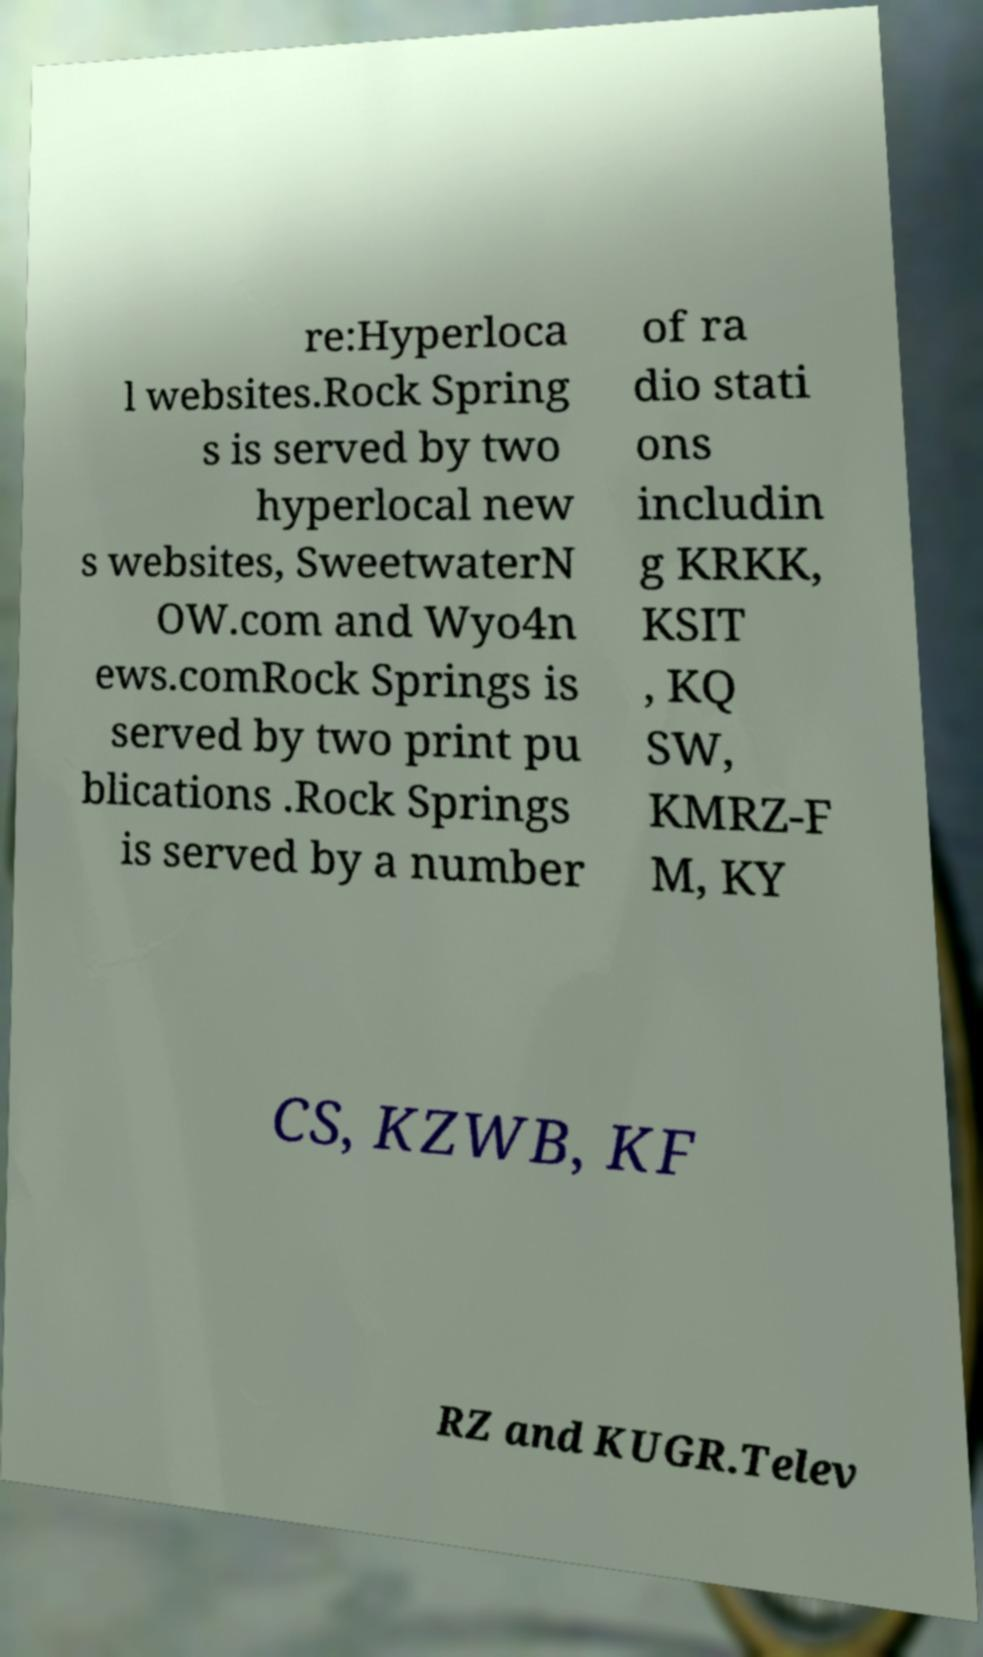Can you accurately transcribe the text from the provided image for me? re:Hyperloca l websites.Rock Spring s is served by two hyperlocal new s websites, SweetwaterN OW.com and Wyo4n ews.comRock Springs is served by two print pu blications .Rock Springs is served by a number of ra dio stati ons includin g KRKK, KSIT , KQ SW, KMRZ-F M, KY CS, KZWB, KF RZ and KUGR.Telev 